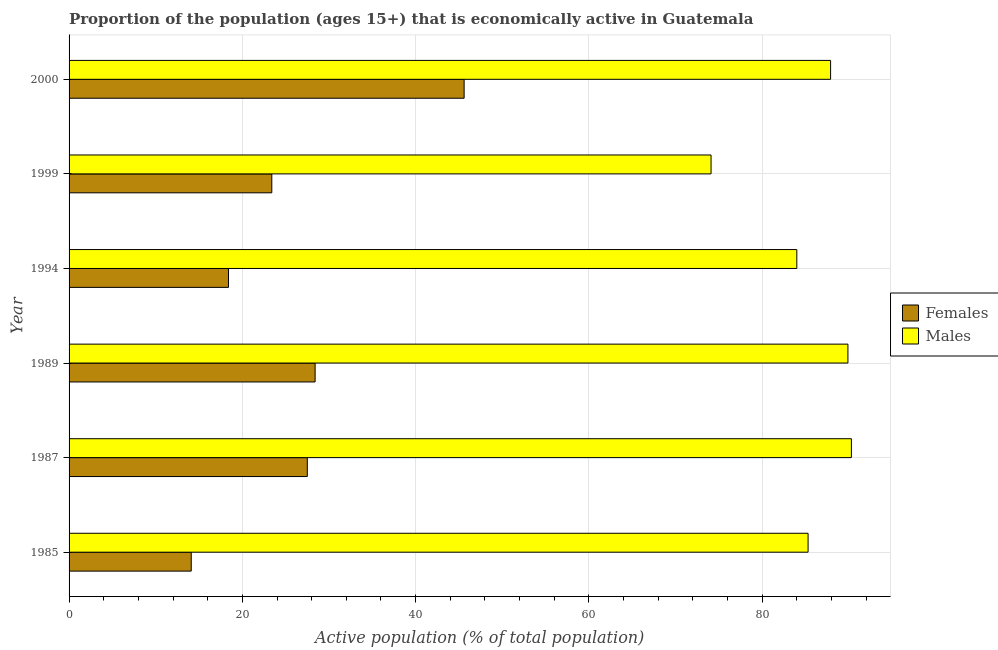Are the number of bars on each tick of the Y-axis equal?
Keep it short and to the point. Yes. How many bars are there on the 2nd tick from the bottom?
Offer a terse response. 2. What is the label of the 2nd group of bars from the top?
Offer a terse response. 1999. What is the percentage of economically active male population in 1989?
Offer a very short reply. 89.9. Across all years, what is the maximum percentage of economically active female population?
Give a very brief answer. 45.6. Across all years, what is the minimum percentage of economically active female population?
Provide a short and direct response. 14.1. In which year was the percentage of economically active female population minimum?
Your answer should be very brief. 1985. What is the total percentage of economically active male population in the graph?
Give a very brief answer. 511.5. What is the difference between the percentage of economically active male population in 1989 and that in 1999?
Give a very brief answer. 15.8. What is the difference between the percentage of economically active female population in 1989 and the percentage of economically active male population in 1994?
Your response must be concise. -55.6. What is the average percentage of economically active female population per year?
Ensure brevity in your answer.  26.23. In the year 1985, what is the difference between the percentage of economically active female population and percentage of economically active male population?
Your answer should be compact. -71.2. In how many years, is the percentage of economically active female population greater than 24 %?
Provide a short and direct response. 3. What is the ratio of the percentage of economically active female population in 1985 to that in 1999?
Provide a succinct answer. 0.6. Is the percentage of economically active female population in 1994 less than that in 1999?
Your answer should be compact. Yes. Is the difference between the percentage of economically active male population in 1987 and 1994 greater than the difference between the percentage of economically active female population in 1987 and 1994?
Make the answer very short. No. What is the difference between the highest and the second highest percentage of economically active female population?
Keep it short and to the point. 17.2. What is the difference between the highest and the lowest percentage of economically active male population?
Your response must be concise. 16.2. In how many years, is the percentage of economically active male population greater than the average percentage of economically active male population taken over all years?
Provide a short and direct response. 4. What does the 1st bar from the top in 1985 represents?
Your answer should be very brief. Males. What does the 2nd bar from the bottom in 1987 represents?
Your answer should be compact. Males. How many bars are there?
Your answer should be very brief. 12. Are all the bars in the graph horizontal?
Offer a very short reply. Yes. How many years are there in the graph?
Ensure brevity in your answer.  6. What is the difference between two consecutive major ticks on the X-axis?
Your answer should be compact. 20. Does the graph contain any zero values?
Ensure brevity in your answer.  No. Where does the legend appear in the graph?
Your answer should be compact. Center right. How many legend labels are there?
Offer a very short reply. 2. How are the legend labels stacked?
Your answer should be very brief. Vertical. What is the title of the graph?
Offer a terse response. Proportion of the population (ages 15+) that is economically active in Guatemala. Does "Urban Population" appear as one of the legend labels in the graph?
Offer a terse response. No. What is the label or title of the X-axis?
Give a very brief answer. Active population (% of total population). What is the Active population (% of total population) of Females in 1985?
Your response must be concise. 14.1. What is the Active population (% of total population) of Males in 1985?
Provide a short and direct response. 85.3. What is the Active population (% of total population) in Females in 1987?
Give a very brief answer. 27.5. What is the Active population (% of total population) in Males in 1987?
Provide a short and direct response. 90.3. What is the Active population (% of total population) in Females in 1989?
Your answer should be very brief. 28.4. What is the Active population (% of total population) of Males in 1989?
Keep it short and to the point. 89.9. What is the Active population (% of total population) in Females in 1994?
Ensure brevity in your answer.  18.4. What is the Active population (% of total population) of Males in 1994?
Make the answer very short. 84. What is the Active population (% of total population) of Females in 1999?
Provide a succinct answer. 23.4. What is the Active population (% of total population) of Males in 1999?
Your answer should be compact. 74.1. What is the Active population (% of total population) of Females in 2000?
Keep it short and to the point. 45.6. What is the Active population (% of total population) in Males in 2000?
Your answer should be compact. 87.9. Across all years, what is the maximum Active population (% of total population) of Females?
Offer a terse response. 45.6. Across all years, what is the maximum Active population (% of total population) in Males?
Provide a succinct answer. 90.3. Across all years, what is the minimum Active population (% of total population) in Females?
Give a very brief answer. 14.1. Across all years, what is the minimum Active population (% of total population) in Males?
Your response must be concise. 74.1. What is the total Active population (% of total population) in Females in the graph?
Provide a short and direct response. 157.4. What is the total Active population (% of total population) in Males in the graph?
Your response must be concise. 511.5. What is the difference between the Active population (% of total population) in Females in 1985 and that in 1987?
Offer a very short reply. -13.4. What is the difference between the Active population (% of total population) of Males in 1985 and that in 1987?
Ensure brevity in your answer.  -5. What is the difference between the Active population (% of total population) in Females in 1985 and that in 1989?
Ensure brevity in your answer.  -14.3. What is the difference between the Active population (% of total population) of Males in 1985 and that in 1989?
Your answer should be very brief. -4.6. What is the difference between the Active population (% of total population) of Females in 1985 and that in 1994?
Give a very brief answer. -4.3. What is the difference between the Active population (% of total population) of Males in 1985 and that in 1994?
Give a very brief answer. 1.3. What is the difference between the Active population (% of total population) in Females in 1985 and that in 1999?
Provide a short and direct response. -9.3. What is the difference between the Active population (% of total population) in Males in 1985 and that in 1999?
Ensure brevity in your answer.  11.2. What is the difference between the Active population (% of total population) of Females in 1985 and that in 2000?
Give a very brief answer. -31.5. What is the difference between the Active population (% of total population) in Males in 1985 and that in 2000?
Provide a succinct answer. -2.6. What is the difference between the Active population (% of total population) in Males in 1987 and that in 1989?
Provide a succinct answer. 0.4. What is the difference between the Active population (% of total population) of Females in 1987 and that in 1994?
Your response must be concise. 9.1. What is the difference between the Active population (% of total population) in Females in 1987 and that in 1999?
Offer a very short reply. 4.1. What is the difference between the Active population (% of total population) in Females in 1987 and that in 2000?
Keep it short and to the point. -18.1. What is the difference between the Active population (% of total population) of Males in 1989 and that in 1994?
Your response must be concise. 5.9. What is the difference between the Active population (% of total population) in Males in 1989 and that in 1999?
Ensure brevity in your answer.  15.8. What is the difference between the Active population (% of total population) in Females in 1989 and that in 2000?
Keep it short and to the point. -17.2. What is the difference between the Active population (% of total population) in Females in 1994 and that in 2000?
Offer a very short reply. -27.2. What is the difference between the Active population (% of total population) in Females in 1999 and that in 2000?
Provide a succinct answer. -22.2. What is the difference between the Active population (% of total population) in Females in 1985 and the Active population (% of total population) in Males in 1987?
Make the answer very short. -76.2. What is the difference between the Active population (% of total population) in Females in 1985 and the Active population (% of total population) in Males in 1989?
Your answer should be compact. -75.8. What is the difference between the Active population (% of total population) in Females in 1985 and the Active population (% of total population) in Males in 1994?
Offer a very short reply. -69.9. What is the difference between the Active population (% of total population) in Females in 1985 and the Active population (% of total population) in Males in 1999?
Offer a terse response. -60. What is the difference between the Active population (% of total population) of Females in 1985 and the Active population (% of total population) of Males in 2000?
Offer a terse response. -73.8. What is the difference between the Active population (% of total population) in Females in 1987 and the Active population (% of total population) in Males in 1989?
Offer a terse response. -62.4. What is the difference between the Active population (% of total population) of Females in 1987 and the Active population (% of total population) of Males in 1994?
Keep it short and to the point. -56.5. What is the difference between the Active population (% of total population) in Females in 1987 and the Active population (% of total population) in Males in 1999?
Make the answer very short. -46.6. What is the difference between the Active population (% of total population) in Females in 1987 and the Active population (% of total population) in Males in 2000?
Ensure brevity in your answer.  -60.4. What is the difference between the Active population (% of total population) in Females in 1989 and the Active population (% of total population) in Males in 1994?
Offer a terse response. -55.6. What is the difference between the Active population (% of total population) in Females in 1989 and the Active population (% of total population) in Males in 1999?
Offer a very short reply. -45.7. What is the difference between the Active population (% of total population) in Females in 1989 and the Active population (% of total population) in Males in 2000?
Your answer should be very brief. -59.5. What is the difference between the Active population (% of total population) of Females in 1994 and the Active population (% of total population) of Males in 1999?
Your response must be concise. -55.7. What is the difference between the Active population (% of total population) in Females in 1994 and the Active population (% of total population) in Males in 2000?
Make the answer very short. -69.5. What is the difference between the Active population (% of total population) in Females in 1999 and the Active population (% of total population) in Males in 2000?
Your answer should be very brief. -64.5. What is the average Active population (% of total population) in Females per year?
Your answer should be compact. 26.23. What is the average Active population (% of total population) of Males per year?
Provide a short and direct response. 85.25. In the year 1985, what is the difference between the Active population (% of total population) in Females and Active population (% of total population) in Males?
Ensure brevity in your answer.  -71.2. In the year 1987, what is the difference between the Active population (% of total population) of Females and Active population (% of total population) of Males?
Keep it short and to the point. -62.8. In the year 1989, what is the difference between the Active population (% of total population) in Females and Active population (% of total population) in Males?
Give a very brief answer. -61.5. In the year 1994, what is the difference between the Active population (% of total population) in Females and Active population (% of total population) in Males?
Your answer should be compact. -65.6. In the year 1999, what is the difference between the Active population (% of total population) of Females and Active population (% of total population) of Males?
Offer a very short reply. -50.7. In the year 2000, what is the difference between the Active population (% of total population) in Females and Active population (% of total population) in Males?
Your answer should be very brief. -42.3. What is the ratio of the Active population (% of total population) in Females in 1985 to that in 1987?
Your answer should be compact. 0.51. What is the ratio of the Active population (% of total population) of Males in 1985 to that in 1987?
Offer a very short reply. 0.94. What is the ratio of the Active population (% of total population) of Females in 1985 to that in 1989?
Provide a succinct answer. 0.5. What is the ratio of the Active population (% of total population) in Males in 1985 to that in 1989?
Your response must be concise. 0.95. What is the ratio of the Active population (% of total population) of Females in 1985 to that in 1994?
Provide a short and direct response. 0.77. What is the ratio of the Active population (% of total population) in Males in 1985 to that in 1994?
Your answer should be very brief. 1.02. What is the ratio of the Active population (% of total population) of Females in 1985 to that in 1999?
Keep it short and to the point. 0.6. What is the ratio of the Active population (% of total population) of Males in 1985 to that in 1999?
Offer a terse response. 1.15. What is the ratio of the Active population (% of total population) of Females in 1985 to that in 2000?
Give a very brief answer. 0.31. What is the ratio of the Active population (% of total population) in Males in 1985 to that in 2000?
Keep it short and to the point. 0.97. What is the ratio of the Active population (% of total population) of Females in 1987 to that in 1989?
Your response must be concise. 0.97. What is the ratio of the Active population (% of total population) of Females in 1987 to that in 1994?
Your response must be concise. 1.49. What is the ratio of the Active population (% of total population) of Males in 1987 to that in 1994?
Offer a terse response. 1.07. What is the ratio of the Active population (% of total population) of Females in 1987 to that in 1999?
Make the answer very short. 1.18. What is the ratio of the Active population (% of total population) of Males in 1987 to that in 1999?
Your answer should be very brief. 1.22. What is the ratio of the Active population (% of total population) in Females in 1987 to that in 2000?
Your answer should be compact. 0.6. What is the ratio of the Active population (% of total population) of Males in 1987 to that in 2000?
Ensure brevity in your answer.  1.03. What is the ratio of the Active population (% of total population) of Females in 1989 to that in 1994?
Provide a short and direct response. 1.54. What is the ratio of the Active population (% of total population) of Males in 1989 to that in 1994?
Provide a short and direct response. 1.07. What is the ratio of the Active population (% of total population) in Females in 1989 to that in 1999?
Your response must be concise. 1.21. What is the ratio of the Active population (% of total population) of Males in 1989 to that in 1999?
Your answer should be very brief. 1.21. What is the ratio of the Active population (% of total population) in Females in 1989 to that in 2000?
Give a very brief answer. 0.62. What is the ratio of the Active population (% of total population) of Males in 1989 to that in 2000?
Offer a terse response. 1.02. What is the ratio of the Active population (% of total population) in Females in 1994 to that in 1999?
Ensure brevity in your answer.  0.79. What is the ratio of the Active population (% of total population) of Males in 1994 to that in 1999?
Offer a very short reply. 1.13. What is the ratio of the Active population (% of total population) of Females in 1994 to that in 2000?
Your response must be concise. 0.4. What is the ratio of the Active population (% of total population) in Males in 1994 to that in 2000?
Provide a short and direct response. 0.96. What is the ratio of the Active population (% of total population) in Females in 1999 to that in 2000?
Offer a terse response. 0.51. What is the ratio of the Active population (% of total population) of Males in 1999 to that in 2000?
Your answer should be very brief. 0.84. What is the difference between the highest and the second highest Active population (% of total population) of Females?
Your answer should be very brief. 17.2. What is the difference between the highest and the lowest Active population (% of total population) of Females?
Keep it short and to the point. 31.5. What is the difference between the highest and the lowest Active population (% of total population) in Males?
Keep it short and to the point. 16.2. 